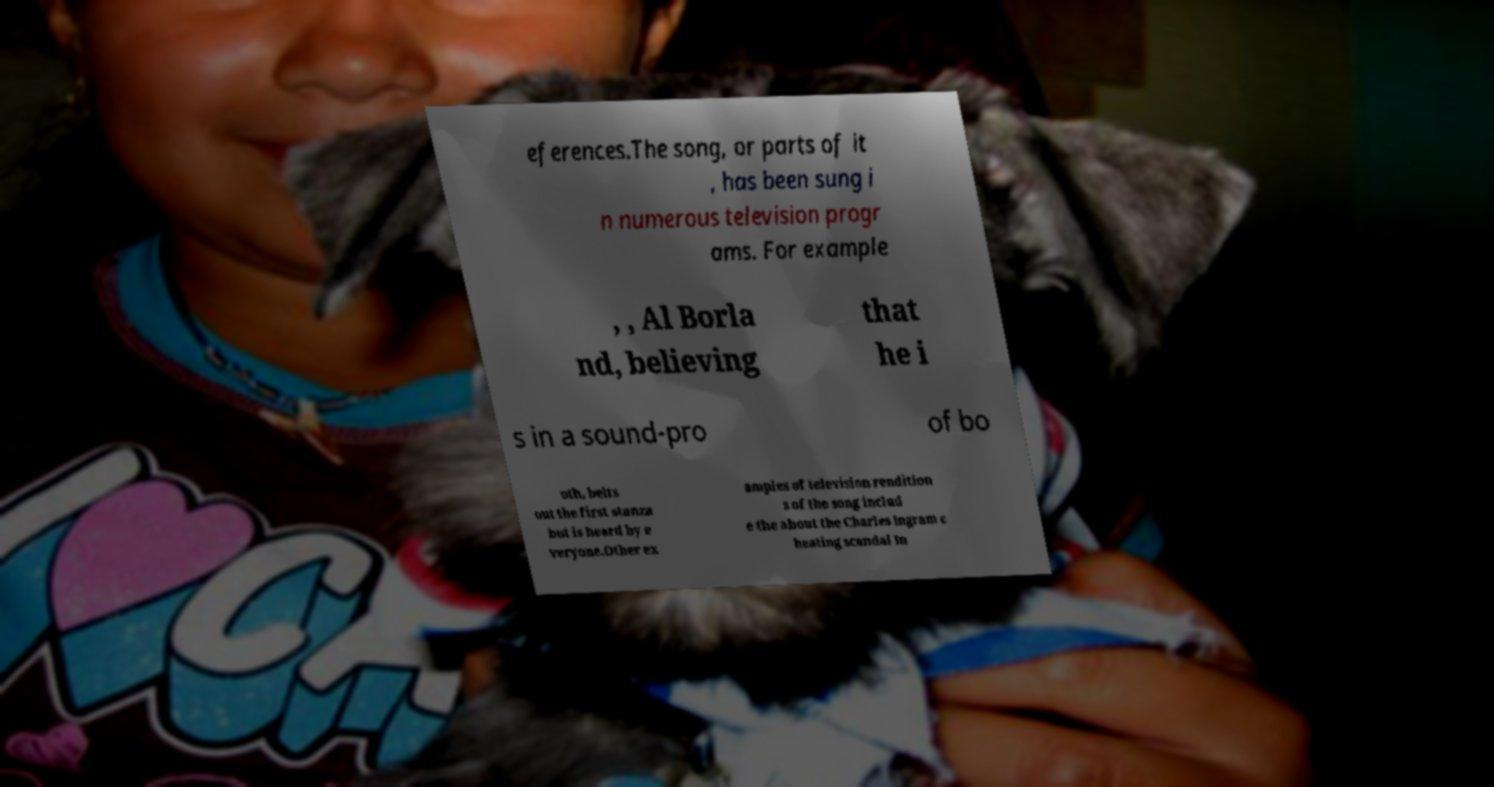For documentation purposes, I need the text within this image transcribed. Could you provide that? eferences.The song, or parts of it , has been sung i n numerous television progr ams. For example , , Al Borla nd, believing that he i s in a sound-pro of bo oth, belts out the first stanza but is heard by e veryone.Other ex amples of television rendition s of the song includ e the about the Charles Ingram c heating scandal In 